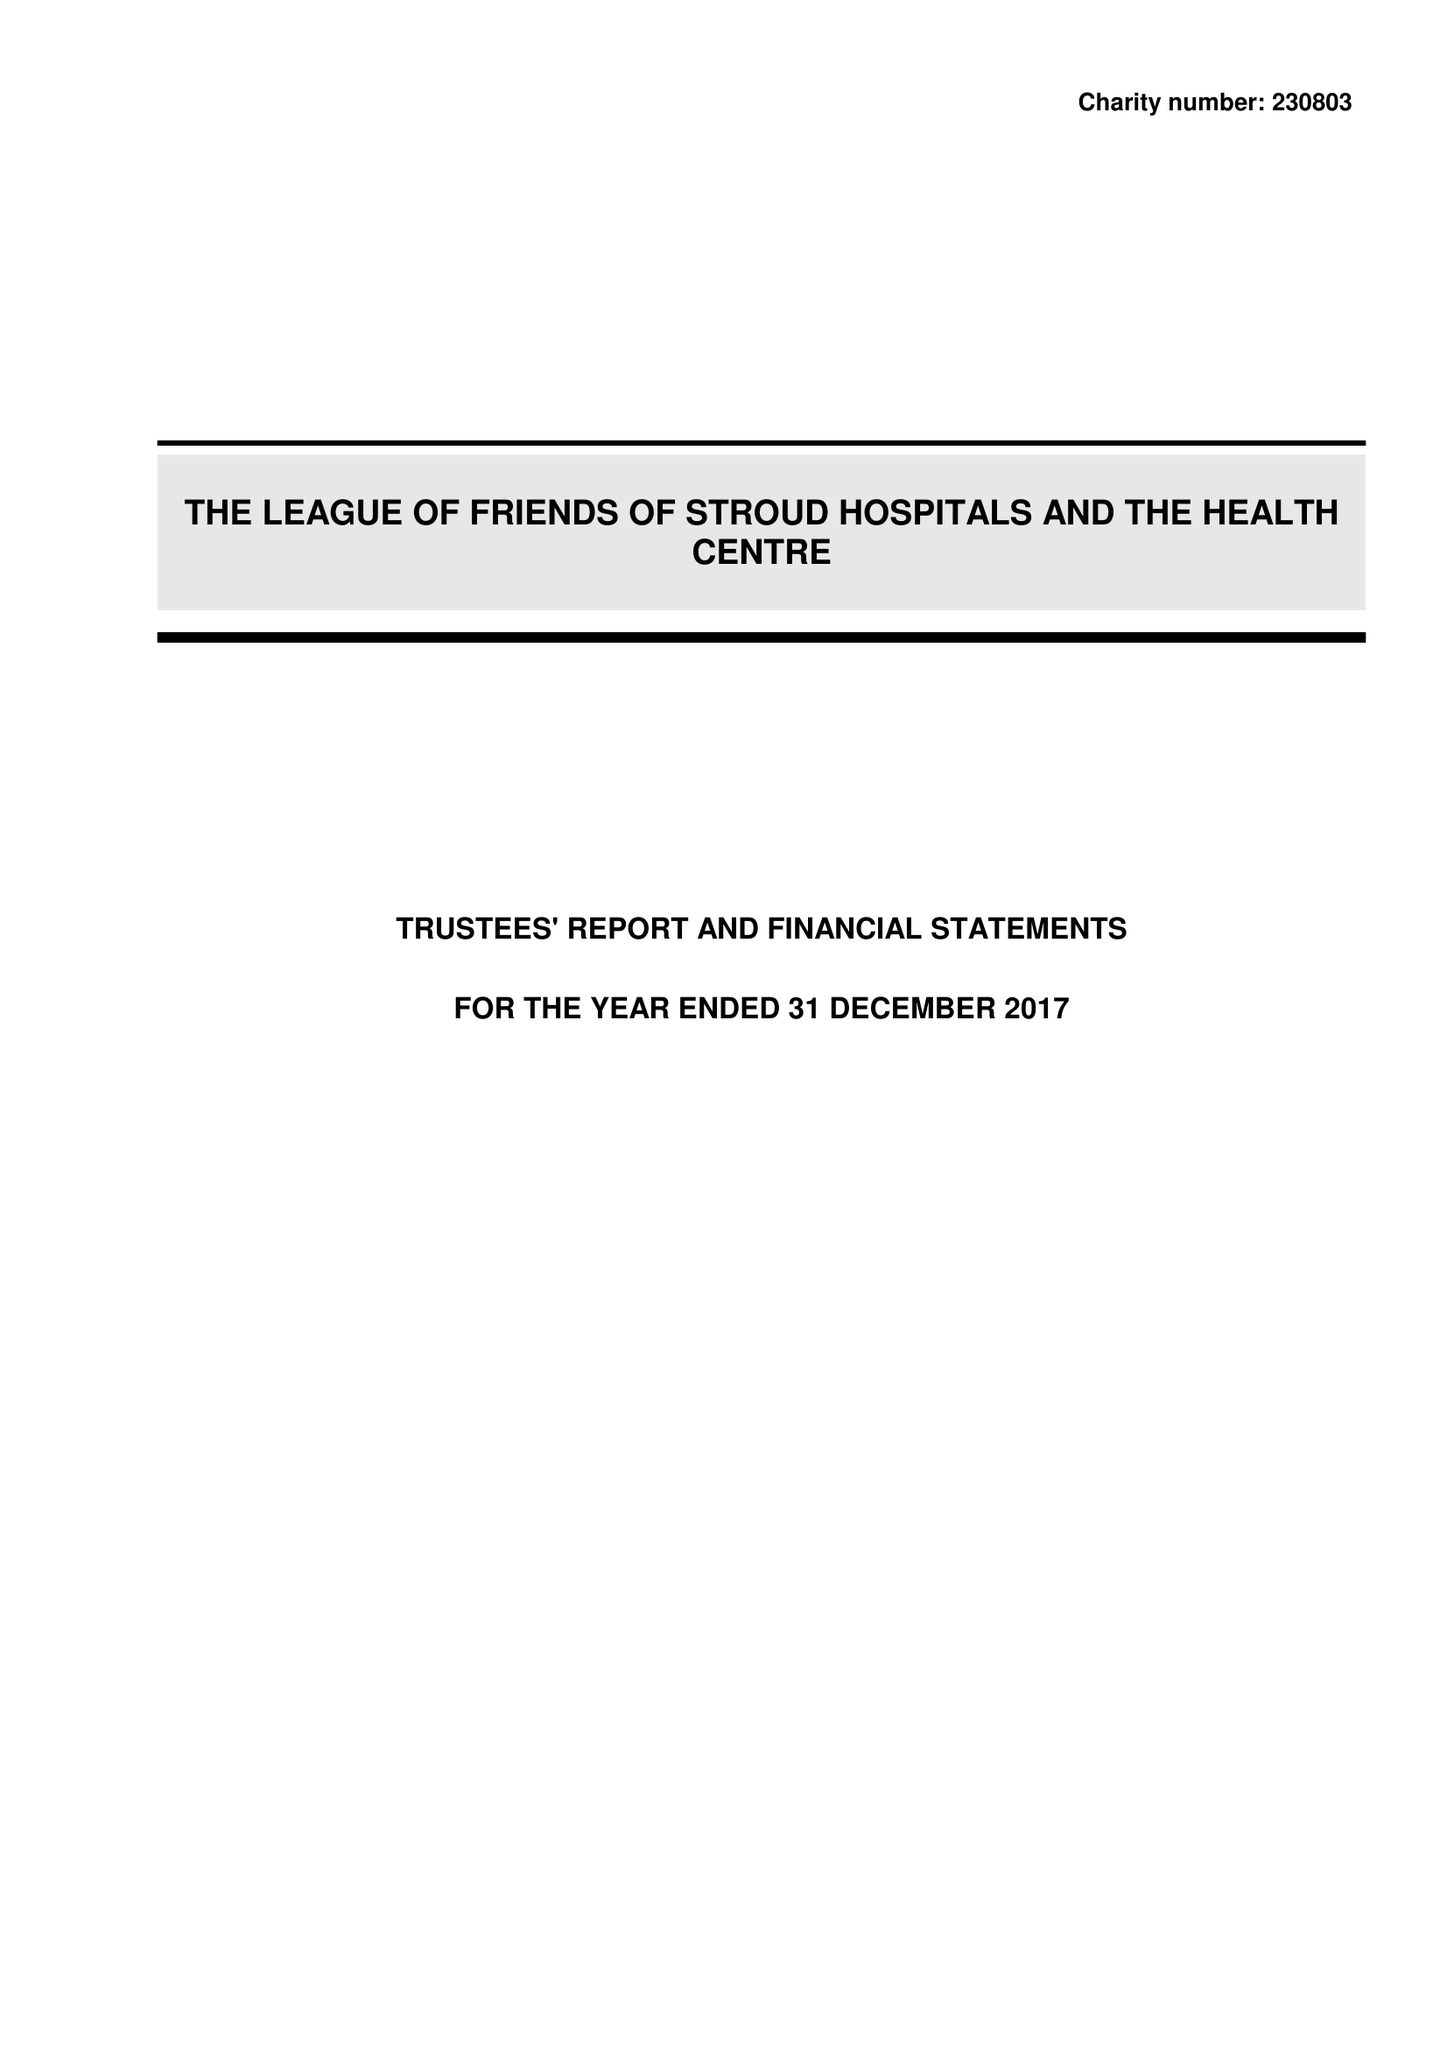What is the value for the report_date?
Answer the question using a single word or phrase. 2017-12-31 